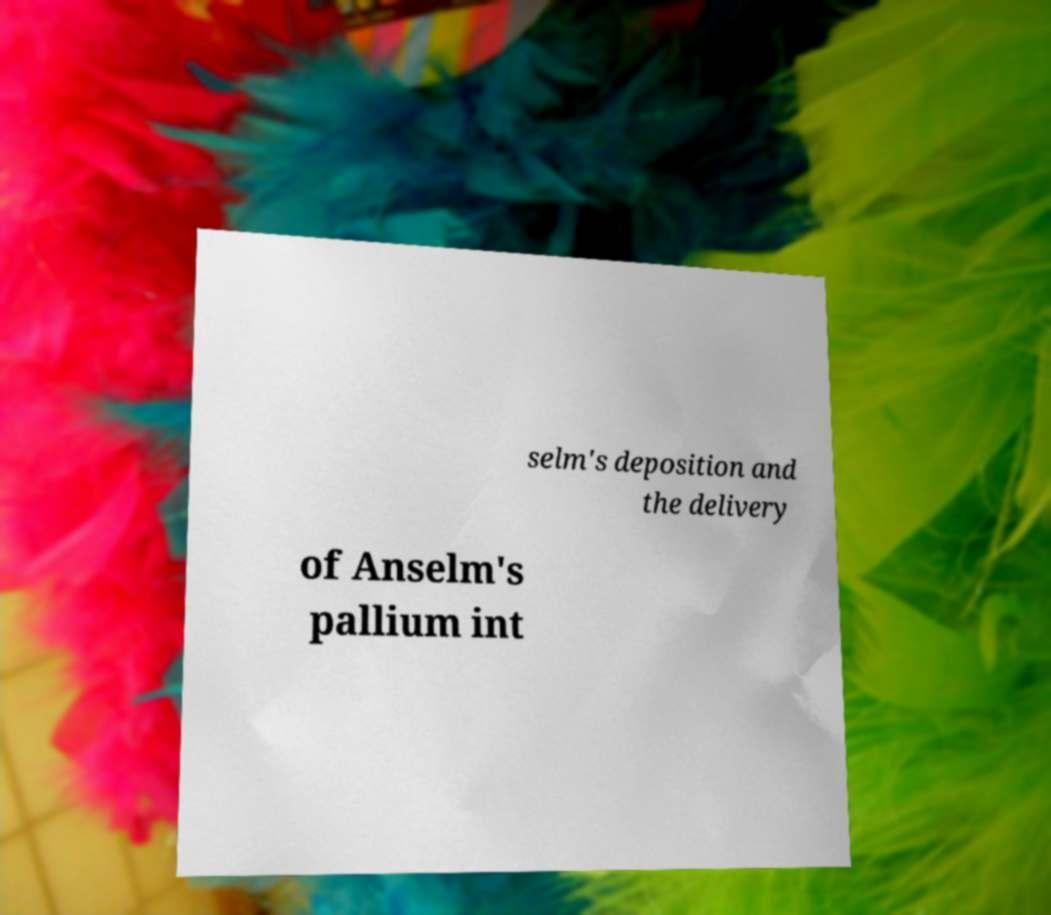For documentation purposes, I need the text within this image transcribed. Could you provide that? selm's deposition and the delivery of Anselm's pallium int 